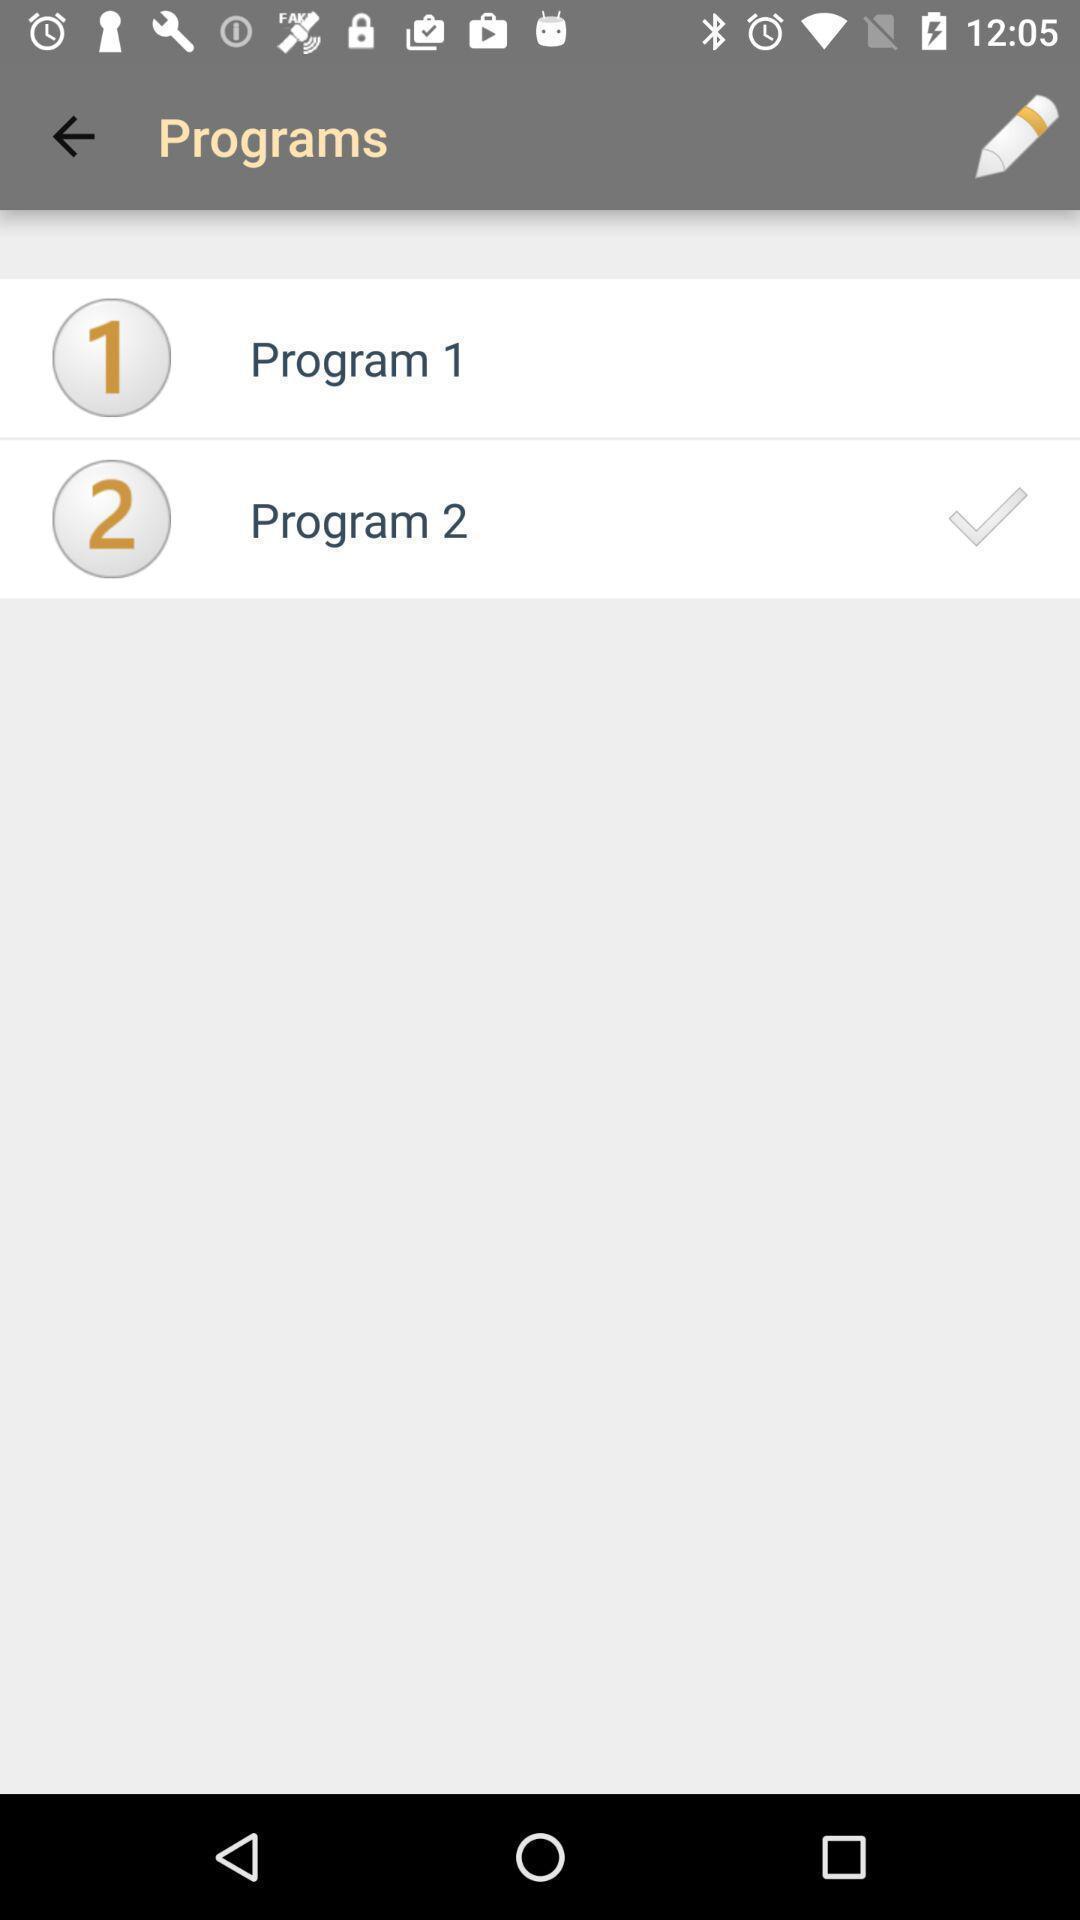Summarize the main components in this picture. Screen shows a programming app. 